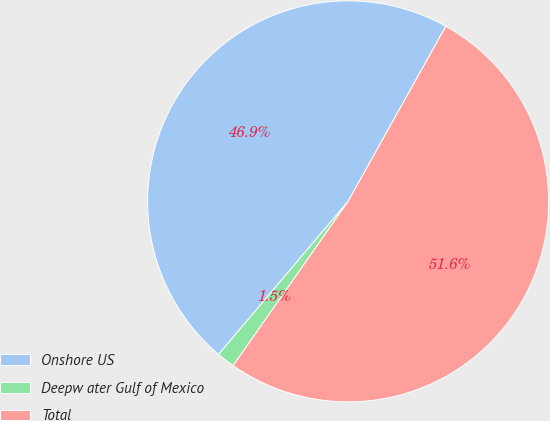<chart> <loc_0><loc_0><loc_500><loc_500><pie_chart><fcel>Onshore US<fcel>Deepw ater Gulf of Mexico<fcel>Total<nl><fcel>46.92%<fcel>1.46%<fcel>51.62%<nl></chart> 